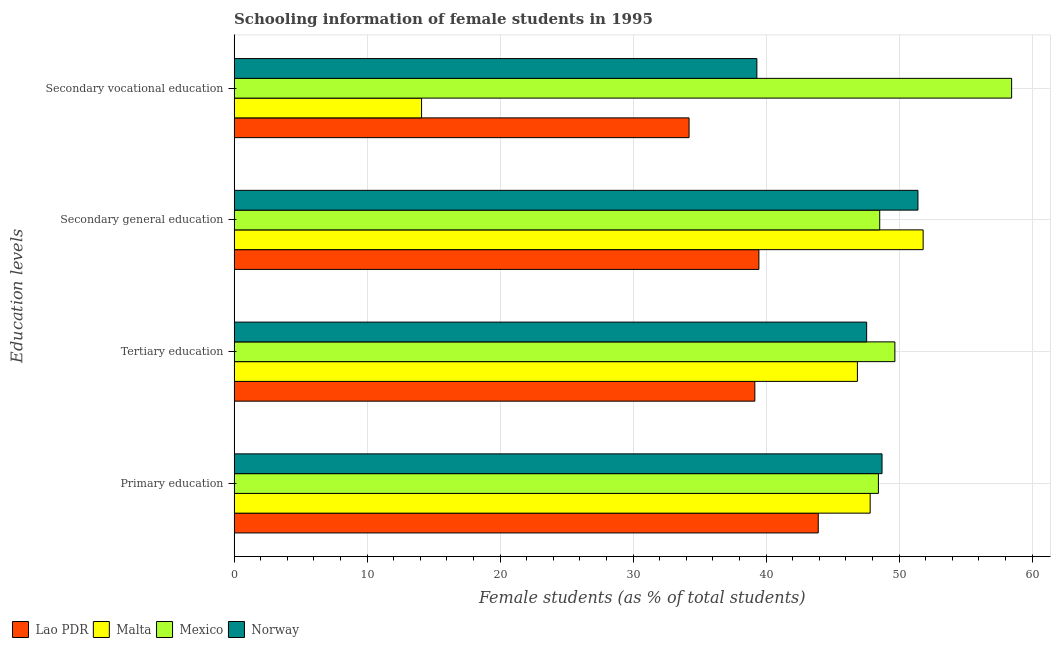How many different coloured bars are there?
Provide a short and direct response. 4. How many groups of bars are there?
Your answer should be compact. 4. How many bars are there on the 3rd tick from the top?
Keep it short and to the point. 4. How many bars are there on the 3rd tick from the bottom?
Offer a very short reply. 4. What is the label of the 3rd group of bars from the top?
Make the answer very short. Tertiary education. What is the percentage of female students in tertiary education in Malta?
Your response must be concise. 46.86. Across all countries, what is the maximum percentage of female students in tertiary education?
Offer a very short reply. 49.68. Across all countries, what is the minimum percentage of female students in secondary education?
Make the answer very short. 39.45. In which country was the percentage of female students in secondary education maximum?
Keep it short and to the point. Malta. In which country was the percentage of female students in tertiary education minimum?
Your answer should be compact. Lao PDR. What is the total percentage of female students in secondary vocational education in the graph?
Provide a short and direct response. 146.06. What is the difference between the percentage of female students in secondary vocational education in Mexico and that in Malta?
Your answer should be compact. 44.36. What is the difference between the percentage of female students in secondary education in Lao PDR and the percentage of female students in tertiary education in Mexico?
Your answer should be compact. -10.23. What is the average percentage of female students in secondary education per country?
Ensure brevity in your answer.  47.8. What is the difference between the percentage of female students in secondary vocational education and percentage of female students in secondary education in Malta?
Provide a succinct answer. -37.71. What is the ratio of the percentage of female students in secondary vocational education in Norway to that in Mexico?
Offer a terse response. 0.67. Is the percentage of female students in secondary vocational education in Lao PDR less than that in Malta?
Keep it short and to the point. No. Is the difference between the percentage of female students in secondary education in Mexico and Norway greater than the difference between the percentage of female students in primary education in Mexico and Norway?
Your response must be concise. No. What is the difference between the highest and the second highest percentage of female students in tertiary education?
Ensure brevity in your answer.  2.12. What is the difference between the highest and the lowest percentage of female students in tertiary education?
Offer a very short reply. 10.53. In how many countries, is the percentage of female students in secondary vocational education greater than the average percentage of female students in secondary vocational education taken over all countries?
Keep it short and to the point. 2. Is it the case that in every country, the sum of the percentage of female students in tertiary education and percentage of female students in secondary vocational education is greater than the sum of percentage of female students in secondary education and percentage of female students in primary education?
Your answer should be compact. No. What does the 3rd bar from the top in Secondary general education represents?
Provide a short and direct response. Malta. Is it the case that in every country, the sum of the percentage of female students in primary education and percentage of female students in tertiary education is greater than the percentage of female students in secondary education?
Your answer should be very brief. Yes. How many bars are there?
Make the answer very short. 16. Are all the bars in the graph horizontal?
Ensure brevity in your answer.  Yes. How many countries are there in the graph?
Make the answer very short. 4. What is the difference between two consecutive major ticks on the X-axis?
Offer a very short reply. 10. Are the values on the major ticks of X-axis written in scientific E-notation?
Keep it short and to the point. No. Does the graph contain any zero values?
Ensure brevity in your answer.  No. What is the title of the graph?
Ensure brevity in your answer.  Schooling information of female students in 1995. Does "High income: nonOECD" appear as one of the legend labels in the graph?
Provide a short and direct response. No. What is the label or title of the X-axis?
Offer a very short reply. Female students (as % of total students). What is the label or title of the Y-axis?
Ensure brevity in your answer.  Education levels. What is the Female students (as % of total students) in Lao PDR in Primary education?
Your answer should be very brief. 43.92. What is the Female students (as % of total students) in Malta in Primary education?
Your answer should be compact. 47.82. What is the Female students (as % of total students) in Mexico in Primary education?
Your response must be concise. 48.44. What is the Female students (as % of total students) of Norway in Primary education?
Provide a short and direct response. 48.71. What is the Female students (as % of total students) of Lao PDR in Tertiary education?
Make the answer very short. 39.15. What is the Female students (as % of total students) in Malta in Tertiary education?
Keep it short and to the point. 46.86. What is the Female students (as % of total students) of Mexico in Tertiary education?
Provide a short and direct response. 49.68. What is the Female students (as % of total students) of Norway in Tertiary education?
Offer a very short reply. 47.56. What is the Female students (as % of total students) in Lao PDR in Secondary general education?
Your answer should be very brief. 39.45. What is the Female students (as % of total students) of Malta in Secondary general education?
Keep it short and to the point. 51.8. What is the Female students (as % of total students) of Mexico in Secondary general education?
Your answer should be very brief. 48.54. What is the Female students (as % of total students) of Norway in Secondary general education?
Keep it short and to the point. 51.41. What is the Female students (as % of total students) of Lao PDR in Secondary vocational education?
Your response must be concise. 34.21. What is the Female students (as % of total students) in Malta in Secondary vocational education?
Ensure brevity in your answer.  14.09. What is the Female students (as % of total students) of Mexico in Secondary vocational education?
Give a very brief answer. 58.46. What is the Female students (as % of total students) of Norway in Secondary vocational education?
Ensure brevity in your answer.  39.3. Across all Education levels, what is the maximum Female students (as % of total students) of Lao PDR?
Offer a very short reply. 43.92. Across all Education levels, what is the maximum Female students (as % of total students) of Malta?
Provide a short and direct response. 51.8. Across all Education levels, what is the maximum Female students (as % of total students) of Mexico?
Your answer should be very brief. 58.46. Across all Education levels, what is the maximum Female students (as % of total students) of Norway?
Make the answer very short. 51.41. Across all Education levels, what is the minimum Female students (as % of total students) of Lao PDR?
Give a very brief answer. 34.21. Across all Education levels, what is the minimum Female students (as % of total students) in Malta?
Make the answer very short. 14.09. Across all Education levels, what is the minimum Female students (as % of total students) of Mexico?
Your answer should be very brief. 48.44. Across all Education levels, what is the minimum Female students (as % of total students) of Norway?
Provide a short and direct response. 39.3. What is the total Female students (as % of total students) of Lao PDR in the graph?
Ensure brevity in your answer.  156.73. What is the total Female students (as % of total students) of Malta in the graph?
Offer a terse response. 160.58. What is the total Female students (as % of total students) of Mexico in the graph?
Your answer should be very brief. 205.12. What is the total Female students (as % of total students) in Norway in the graph?
Offer a very short reply. 186.99. What is the difference between the Female students (as % of total students) of Lao PDR in Primary education and that in Tertiary education?
Make the answer very short. 4.77. What is the difference between the Female students (as % of total students) in Malta in Primary education and that in Tertiary education?
Offer a terse response. 0.96. What is the difference between the Female students (as % of total students) in Mexico in Primary education and that in Tertiary education?
Offer a terse response. -1.24. What is the difference between the Female students (as % of total students) of Norway in Primary education and that in Tertiary education?
Your response must be concise. 1.16. What is the difference between the Female students (as % of total students) of Lao PDR in Primary education and that in Secondary general education?
Your answer should be very brief. 4.46. What is the difference between the Female students (as % of total students) in Malta in Primary education and that in Secondary general education?
Make the answer very short. -3.98. What is the difference between the Female students (as % of total students) of Mexico in Primary education and that in Secondary general education?
Offer a terse response. -0.1. What is the difference between the Female students (as % of total students) in Norway in Primary education and that in Secondary general education?
Make the answer very short. -2.7. What is the difference between the Female students (as % of total students) of Lao PDR in Primary education and that in Secondary vocational education?
Make the answer very short. 9.71. What is the difference between the Female students (as % of total students) of Malta in Primary education and that in Secondary vocational education?
Your answer should be very brief. 33.73. What is the difference between the Female students (as % of total students) in Mexico in Primary education and that in Secondary vocational education?
Make the answer very short. -10.02. What is the difference between the Female students (as % of total students) of Norway in Primary education and that in Secondary vocational education?
Your answer should be very brief. 9.41. What is the difference between the Female students (as % of total students) of Lao PDR in Tertiary education and that in Secondary general education?
Your answer should be compact. -0.3. What is the difference between the Female students (as % of total students) in Malta in Tertiary education and that in Secondary general education?
Your response must be concise. -4.94. What is the difference between the Female students (as % of total students) of Mexico in Tertiary education and that in Secondary general education?
Keep it short and to the point. 1.14. What is the difference between the Female students (as % of total students) of Norway in Tertiary education and that in Secondary general education?
Keep it short and to the point. -3.86. What is the difference between the Female students (as % of total students) of Lao PDR in Tertiary education and that in Secondary vocational education?
Make the answer very short. 4.95. What is the difference between the Female students (as % of total students) in Malta in Tertiary education and that in Secondary vocational education?
Provide a short and direct response. 32.77. What is the difference between the Female students (as % of total students) of Mexico in Tertiary education and that in Secondary vocational education?
Keep it short and to the point. -8.78. What is the difference between the Female students (as % of total students) of Norway in Tertiary education and that in Secondary vocational education?
Provide a succinct answer. 8.25. What is the difference between the Female students (as % of total students) in Lao PDR in Secondary general education and that in Secondary vocational education?
Make the answer very short. 5.25. What is the difference between the Female students (as % of total students) of Malta in Secondary general education and that in Secondary vocational education?
Ensure brevity in your answer.  37.71. What is the difference between the Female students (as % of total students) of Mexico in Secondary general education and that in Secondary vocational education?
Offer a very short reply. -9.92. What is the difference between the Female students (as % of total students) of Norway in Secondary general education and that in Secondary vocational education?
Make the answer very short. 12.11. What is the difference between the Female students (as % of total students) in Lao PDR in Primary education and the Female students (as % of total students) in Malta in Tertiary education?
Your answer should be compact. -2.94. What is the difference between the Female students (as % of total students) of Lao PDR in Primary education and the Female students (as % of total students) of Mexico in Tertiary education?
Your answer should be very brief. -5.76. What is the difference between the Female students (as % of total students) of Lao PDR in Primary education and the Female students (as % of total students) of Norway in Tertiary education?
Your response must be concise. -3.64. What is the difference between the Female students (as % of total students) in Malta in Primary education and the Female students (as % of total students) in Mexico in Tertiary education?
Provide a short and direct response. -1.86. What is the difference between the Female students (as % of total students) in Malta in Primary education and the Female students (as % of total students) in Norway in Tertiary education?
Your answer should be compact. 0.26. What is the difference between the Female students (as % of total students) of Mexico in Primary education and the Female students (as % of total students) of Norway in Tertiary education?
Your answer should be compact. 0.88. What is the difference between the Female students (as % of total students) of Lao PDR in Primary education and the Female students (as % of total students) of Malta in Secondary general education?
Provide a short and direct response. -7.89. What is the difference between the Female students (as % of total students) of Lao PDR in Primary education and the Female students (as % of total students) of Mexico in Secondary general education?
Provide a short and direct response. -4.62. What is the difference between the Female students (as % of total students) in Lao PDR in Primary education and the Female students (as % of total students) in Norway in Secondary general education?
Offer a very short reply. -7.5. What is the difference between the Female students (as % of total students) of Malta in Primary education and the Female students (as % of total students) of Mexico in Secondary general education?
Keep it short and to the point. -0.72. What is the difference between the Female students (as % of total students) in Malta in Primary education and the Female students (as % of total students) in Norway in Secondary general education?
Ensure brevity in your answer.  -3.59. What is the difference between the Female students (as % of total students) of Mexico in Primary education and the Female students (as % of total students) of Norway in Secondary general education?
Make the answer very short. -2.97. What is the difference between the Female students (as % of total students) of Lao PDR in Primary education and the Female students (as % of total students) of Malta in Secondary vocational education?
Offer a terse response. 29.83. What is the difference between the Female students (as % of total students) in Lao PDR in Primary education and the Female students (as % of total students) in Mexico in Secondary vocational education?
Give a very brief answer. -14.54. What is the difference between the Female students (as % of total students) of Lao PDR in Primary education and the Female students (as % of total students) of Norway in Secondary vocational education?
Offer a terse response. 4.61. What is the difference between the Female students (as % of total students) of Malta in Primary education and the Female students (as % of total students) of Mexico in Secondary vocational education?
Offer a very short reply. -10.64. What is the difference between the Female students (as % of total students) of Malta in Primary education and the Female students (as % of total students) of Norway in Secondary vocational education?
Make the answer very short. 8.52. What is the difference between the Female students (as % of total students) in Mexico in Primary education and the Female students (as % of total students) in Norway in Secondary vocational education?
Your answer should be compact. 9.14. What is the difference between the Female students (as % of total students) in Lao PDR in Tertiary education and the Female students (as % of total students) in Malta in Secondary general education?
Offer a very short reply. -12.65. What is the difference between the Female students (as % of total students) in Lao PDR in Tertiary education and the Female students (as % of total students) in Mexico in Secondary general education?
Ensure brevity in your answer.  -9.39. What is the difference between the Female students (as % of total students) in Lao PDR in Tertiary education and the Female students (as % of total students) in Norway in Secondary general education?
Give a very brief answer. -12.26. What is the difference between the Female students (as % of total students) of Malta in Tertiary education and the Female students (as % of total students) of Mexico in Secondary general education?
Offer a terse response. -1.68. What is the difference between the Female students (as % of total students) of Malta in Tertiary education and the Female students (as % of total students) of Norway in Secondary general education?
Provide a short and direct response. -4.55. What is the difference between the Female students (as % of total students) in Mexico in Tertiary education and the Female students (as % of total students) in Norway in Secondary general education?
Give a very brief answer. -1.73. What is the difference between the Female students (as % of total students) of Lao PDR in Tertiary education and the Female students (as % of total students) of Malta in Secondary vocational education?
Give a very brief answer. 25.06. What is the difference between the Female students (as % of total students) in Lao PDR in Tertiary education and the Female students (as % of total students) in Mexico in Secondary vocational education?
Your response must be concise. -19.31. What is the difference between the Female students (as % of total students) in Lao PDR in Tertiary education and the Female students (as % of total students) in Norway in Secondary vocational education?
Ensure brevity in your answer.  -0.15. What is the difference between the Female students (as % of total students) in Malta in Tertiary education and the Female students (as % of total students) in Mexico in Secondary vocational education?
Your response must be concise. -11.59. What is the difference between the Female students (as % of total students) of Malta in Tertiary education and the Female students (as % of total students) of Norway in Secondary vocational education?
Ensure brevity in your answer.  7.56. What is the difference between the Female students (as % of total students) in Mexico in Tertiary education and the Female students (as % of total students) in Norway in Secondary vocational education?
Give a very brief answer. 10.38. What is the difference between the Female students (as % of total students) of Lao PDR in Secondary general education and the Female students (as % of total students) of Malta in Secondary vocational education?
Keep it short and to the point. 25.36. What is the difference between the Female students (as % of total students) in Lao PDR in Secondary general education and the Female students (as % of total students) in Mexico in Secondary vocational education?
Give a very brief answer. -19. What is the difference between the Female students (as % of total students) in Lao PDR in Secondary general education and the Female students (as % of total students) in Norway in Secondary vocational education?
Ensure brevity in your answer.  0.15. What is the difference between the Female students (as % of total students) of Malta in Secondary general education and the Female students (as % of total students) of Mexico in Secondary vocational education?
Keep it short and to the point. -6.65. What is the difference between the Female students (as % of total students) in Malta in Secondary general education and the Female students (as % of total students) in Norway in Secondary vocational education?
Your answer should be very brief. 12.5. What is the difference between the Female students (as % of total students) of Mexico in Secondary general education and the Female students (as % of total students) of Norway in Secondary vocational education?
Your answer should be compact. 9.24. What is the average Female students (as % of total students) of Lao PDR per Education levels?
Give a very brief answer. 39.18. What is the average Female students (as % of total students) in Malta per Education levels?
Provide a succinct answer. 40.15. What is the average Female students (as % of total students) of Mexico per Education levels?
Your answer should be compact. 51.28. What is the average Female students (as % of total students) of Norway per Education levels?
Your answer should be compact. 46.75. What is the difference between the Female students (as % of total students) of Lao PDR and Female students (as % of total students) of Malta in Primary education?
Provide a short and direct response. -3.9. What is the difference between the Female students (as % of total students) in Lao PDR and Female students (as % of total students) in Mexico in Primary education?
Keep it short and to the point. -4.52. What is the difference between the Female students (as % of total students) in Lao PDR and Female students (as % of total students) in Norway in Primary education?
Your response must be concise. -4.8. What is the difference between the Female students (as % of total students) in Malta and Female students (as % of total students) in Mexico in Primary education?
Give a very brief answer. -0.62. What is the difference between the Female students (as % of total students) of Malta and Female students (as % of total students) of Norway in Primary education?
Your response must be concise. -0.89. What is the difference between the Female students (as % of total students) of Mexico and Female students (as % of total students) of Norway in Primary education?
Give a very brief answer. -0.27. What is the difference between the Female students (as % of total students) of Lao PDR and Female students (as % of total students) of Malta in Tertiary education?
Your response must be concise. -7.71. What is the difference between the Female students (as % of total students) of Lao PDR and Female students (as % of total students) of Mexico in Tertiary education?
Offer a terse response. -10.53. What is the difference between the Female students (as % of total students) of Lao PDR and Female students (as % of total students) of Norway in Tertiary education?
Ensure brevity in your answer.  -8.41. What is the difference between the Female students (as % of total students) of Malta and Female students (as % of total students) of Mexico in Tertiary education?
Give a very brief answer. -2.82. What is the difference between the Female students (as % of total students) of Malta and Female students (as % of total students) of Norway in Tertiary education?
Provide a short and direct response. -0.69. What is the difference between the Female students (as % of total students) of Mexico and Female students (as % of total students) of Norway in Tertiary education?
Your answer should be compact. 2.12. What is the difference between the Female students (as % of total students) of Lao PDR and Female students (as % of total students) of Malta in Secondary general education?
Provide a short and direct response. -12.35. What is the difference between the Female students (as % of total students) of Lao PDR and Female students (as % of total students) of Mexico in Secondary general education?
Your answer should be very brief. -9.09. What is the difference between the Female students (as % of total students) of Lao PDR and Female students (as % of total students) of Norway in Secondary general education?
Make the answer very short. -11.96. What is the difference between the Female students (as % of total students) in Malta and Female students (as % of total students) in Mexico in Secondary general education?
Keep it short and to the point. 3.26. What is the difference between the Female students (as % of total students) of Malta and Female students (as % of total students) of Norway in Secondary general education?
Provide a succinct answer. 0.39. What is the difference between the Female students (as % of total students) in Mexico and Female students (as % of total students) in Norway in Secondary general education?
Give a very brief answer. -2.87. What is the difference between the Female students (as % of total students) of Lao PDR and Female students (as % of total students) of Malta in Secondary vocational education?
Provide a short and direct response. 20.11. What is the difference between the Female students (as % of total students) in Lao PDR and Female students (as % of total students) in Mexico in Secondary vocational education?
Offer a very short reply. -24.25. What is the difference between the Female students (as % of total students) in Lao PDR and Female students (as % of total students) in Norway in Secondary vocational education?
Your response must be concise. -5.1. What is the difference between the Female students (as % of total students) in Malta and Female students (as % of total students) in Mexico in Secondary vocational education?
Ensure brevity in your answer.  -44.36. What is the difference between the Female students (as % of total students) in Malta and Female students (as % of total students) in Norway in Secondary vocational education?
Your answer should be compact. -25.21. What is the difference between the Female students (as % of total students) in Mexico and Female students (as % of total students) in Norway in Secondary vocational education?
Give a very brief answer. 19.15. What is the ratio of the Female students (as % of total students) of Lao PDR in Primary education to that in Tertiary education?
Ensure brevity in your answer.  1.12. What is the ratio of the Female students (as % of total students) in Malta in Primary education to that in Tertiary education?
Your response must be concise. 1.02. What is the ratio of the Female students (as % of total students) in Mexico in Primary education to that in Tertiary education?
Make the answer very short. 0.98. What is the ratio of the Female students (as % of total students) in Norway in Primary education to that in Tertiary education?
Ensure brevity in your answer.  1.02. What is the ratio of the Female students (as % of total students) of Lao PDR in Primary education to that in Secondary general education?
Your response must be concise. 1.11. What is the ratio of the Female students (as % of total students) of Mexico in Primary education to that in Secondary general education?
Make the answer very short. 1. What is the ratio of the Female students (as % of total students) of Norway in Primary education to that in Secondary general education?
Provide a succinct answer. 0.95. What is the ratio of the Female students (as % of total students) in Lao PDR in Primary education to that in Secondary vocational education?
Make the answer very short. 1.28. What is the ratio of the Female students (as % of total students) in Malta in Primary education to that in Secondary vocational education?
Your response must be concise. 3.39. What is the ratio of the Female students (as % of total students) in Mexico in Primary education to that in Secondary vocational education?
Your answer should be compact. 0.83. What is the ratio of the Female students (as % of total students) of Norway in Primary education to that in Secondary vocational education?
Offer a terse response. 1.24. What is the ratio of the Female students (as % of total students) of Malta in Tertiary education to that in Secondary general education?
Provide a succinct answer. 0.9. What is the ratio of the Female students (as % of total students) of Mexico in Tertiary education to that in Secondary general education?
Your answer should be very brief. 1.02. What is the ratio of the Female students (as % of total students) of Norway in Tertiary education to that in Secondary general education?
Ensure brevity in your answer.  0.93. What is the ratio of the Female students (as % of total students) of Lao PDR in Tertiary education to that in Secondary vocational education?
Offer a very short reply. 1.14. What is the ratio of the Female students (as % of total students) in Malta in Tertiary education to that in Secondary vocational education?
Make the answer very short. 3.33. What is the ratio of the Female students (as % of total students) of Mexico in Tertiary education to that in Secondary vocational education?
Offer a terse response. 0.85. What is the ratio of the Female students (as % of total students) of Norway in Tertiary education to that in Secondary vocational education?
Offer a very short reply. 1.21. What is the ratio of the Female students (as % of total students) in Lao PDR in Secondary general education to that in Secondary vocational education?
Ensure brevity in your answer.  1.15. What is the ratio of the Female students (as % of total students) in Malta in Secondary general education to that in Secondary vocational education?
Provide a succinct answer. 3.68. What is the ratio of the Female students (as % of total students) in Mexico in Secondary general education to that in Secondary vocational education?
Keep it short and to the point. 0.83. What is the ratio of the Female students (as % of total students) in Norway in Secondary general education to that in Secondary vocational education?
Keep it short and to the point. 1.31. What is the difference between the highest and the second highest Female students (as % of total students) in Lao PDR?
Your answer should be compact. 4.46. What is the difference between the highest and the second highest Female students (as % of total students) of Malta?
Offer a terse response. 3.98. What is the difference between the highest and the second highest Female students (as % of total students) of Mexico?
Offer a very short reply. 8.78. What is the difference between the highest and the second highest Female students (as % of total students) of Norway?
Your response must be concise. 2.7. What is the difference between the highest and the lowest Female students (as % of total students) in Lao PDR?
Provide a succinct answer. 9.71. What is the difference between the highest and the lowest Female students (as % of total students) of Malta?
Your response must be concise. 37.71. What is the difference between the highest and the lowest Female students (as % of total students) of Mexico?
Your answer should be compact. 10.02. What is the difference between the highest and the lowest Female students (as % of total students) in Norway?
Your answer should be compact. 12.11. 